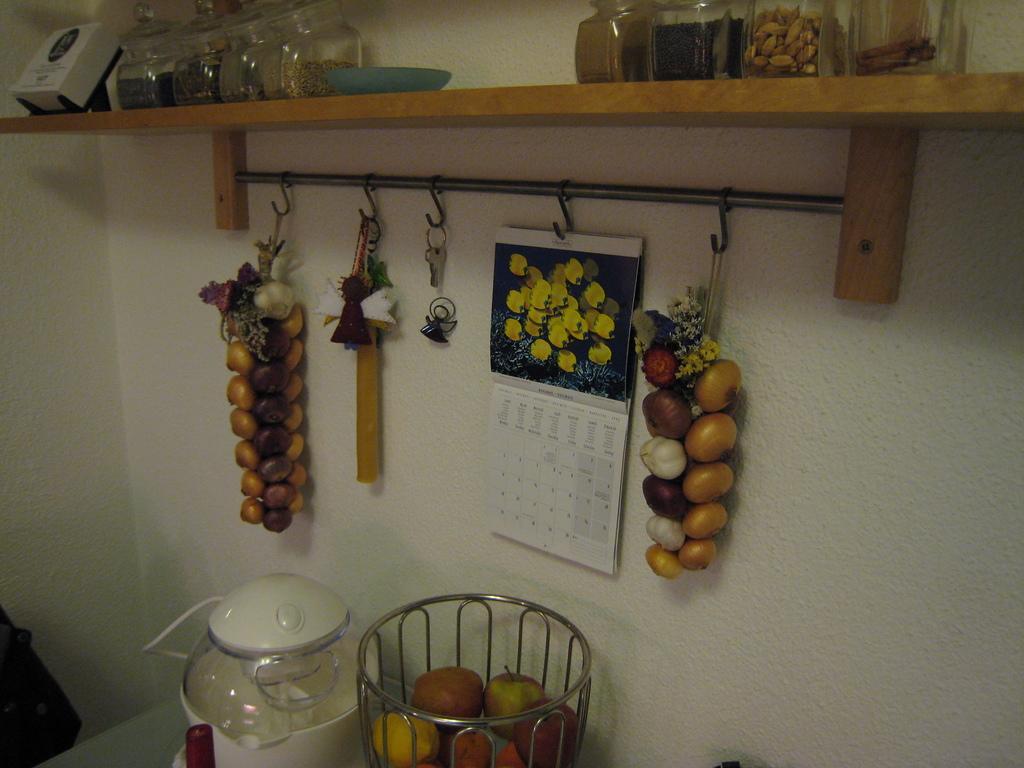Please provide a concise description of this image. In this picture I can observe some fruits and vegetables hanged to the hangers. In the middle of the picture there is a calendar. In the bottom of the picture I can observe some fruits. In the top of the picture I can observe some glass jars placed on the wooden surface. In the background there is a wall. 